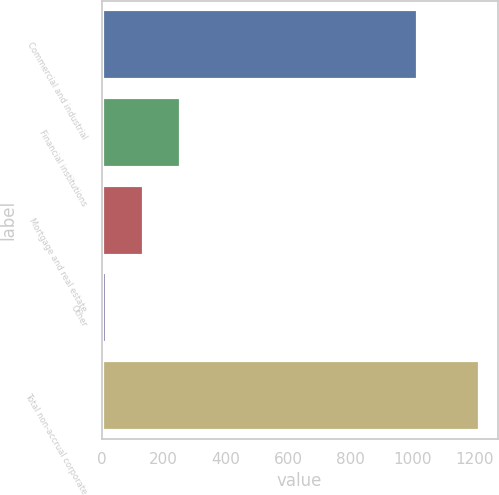<chart> <loc_0><loc_0><loc_500><loc_500><bar_chart><fcel>Commercial and industrial<fcel>Financial institutions<fcel>Mortgage and real estate<fcel>Other<fcel>Total non-accrual corporate<nl><fcel>1017<fcel>253.4<fcel>133.2<fcel>13<fcel>1215<nl></chart> 